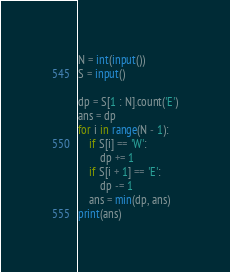Convert code to text. <code><loc_0><loc_0><loc_500><loc_500><_Python_>N = int(input())
S = input()

dp = S[1 : N].count('E')
ans = dp
for i in range(N - 1):
    if S[i] == 'W':
        dp += 1
    if S[i + 1] == 'E':
        dp -= 1
    ans = min(dp, ans)
print(ans)</code> 